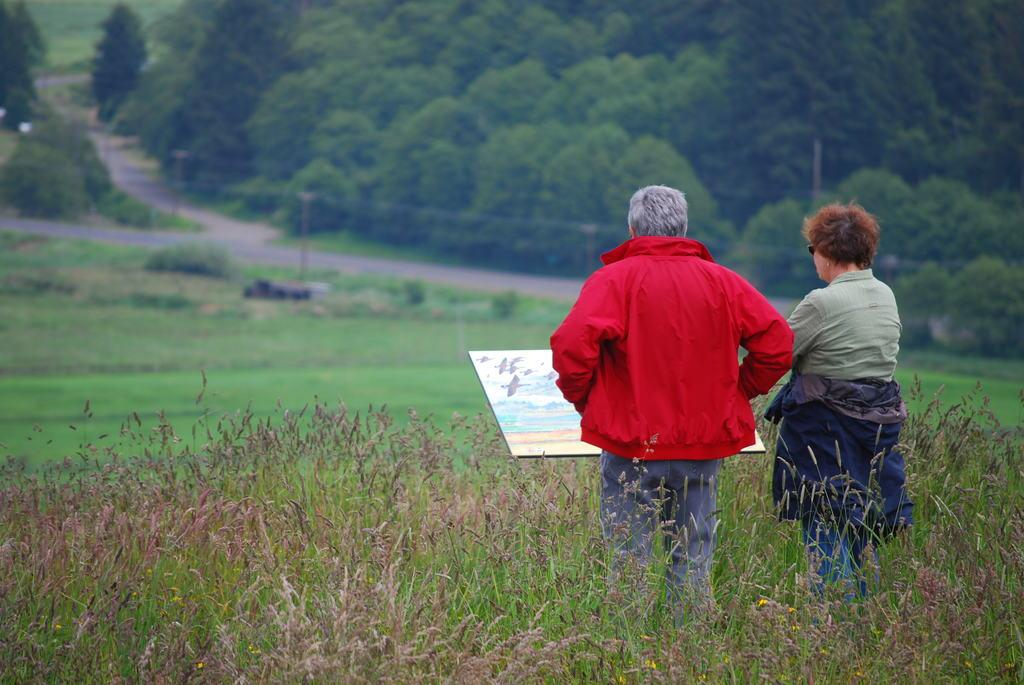How many people are present in the image? There are two people, a man and a woman, present in the image. What are the man and woman standing on? Both the man and woman are standing on the grass. What can be seen in the background of the image? There is a board, a pole, trees, grass, and plants in the background of the image. What type of cactus can be seen in the image? There is no cactus present in the image. What is the stove used for in the image? There is no stove present in the image. 